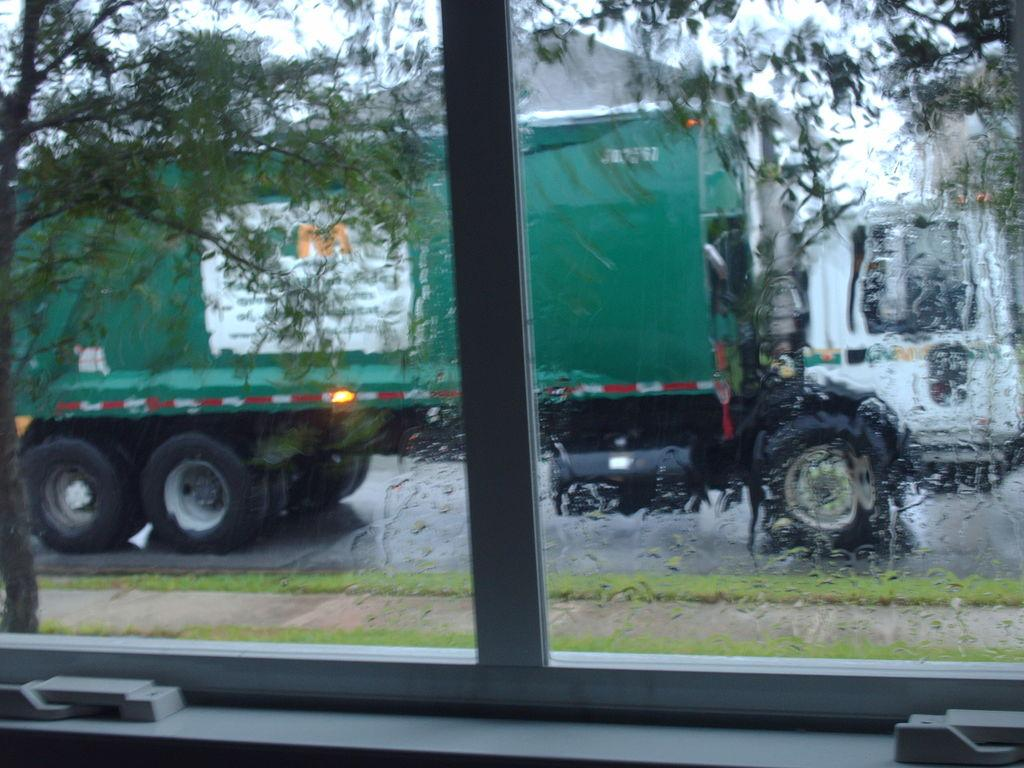What type of view is shown in the image? The image is an inside view. What object in the image provides a view of the outside? There is a glass in the image that provides a view of the outside. What can be seen outside through the glass? Trees, a building, and a vehicle on the road are visible outside. What is the yak using to carry the milk in the image? There is no yak or milk present in the image. 